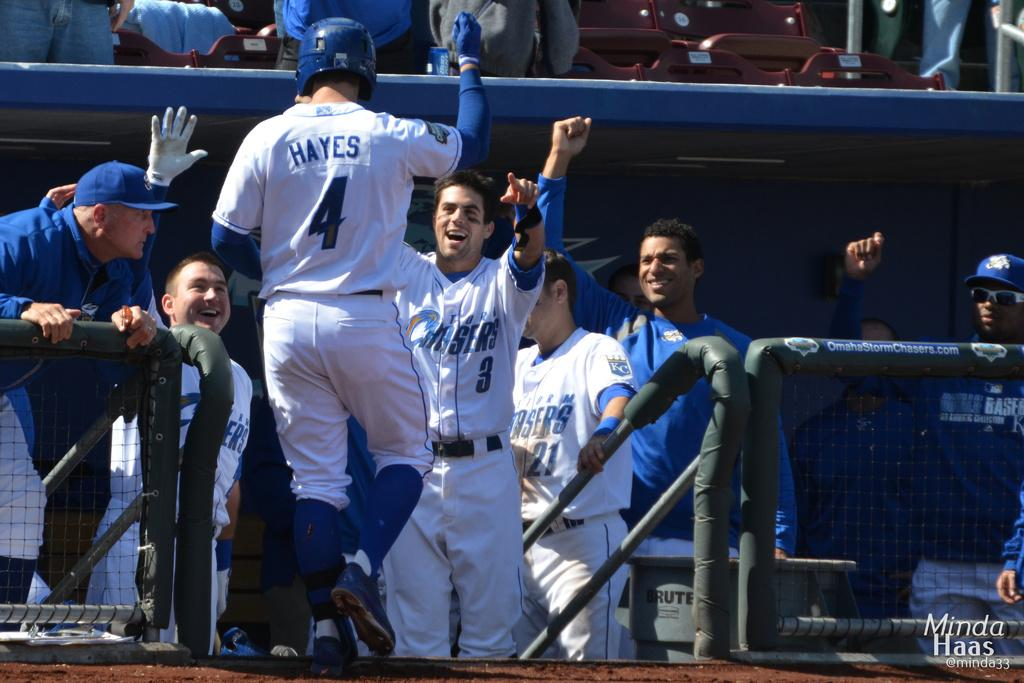Provide a one-sentence caption for the provided image. baseball players are celebrating in white and blue uniforms that say Chasers on them. 